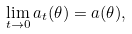<formula> <loc_0><loc_0><loc_500><loc_500>\lim _ { t \to 0 } \L a _ { t } ( \theta ) = \L a ( \theta ) ,</formula> 